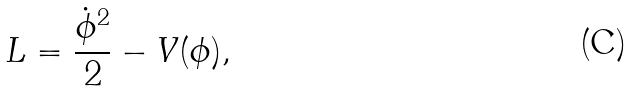<formula> <loc_0><loc_0><loc_500><loc_500>L = \frac { \dot { \phi } ^ { 2 } } { 2 } - V ( \phi ) ,</formula> 